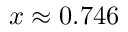<formula> <loc_0><loc_0><loc_500><loc_500>x \approx 0 . 7 4 6</formula> 